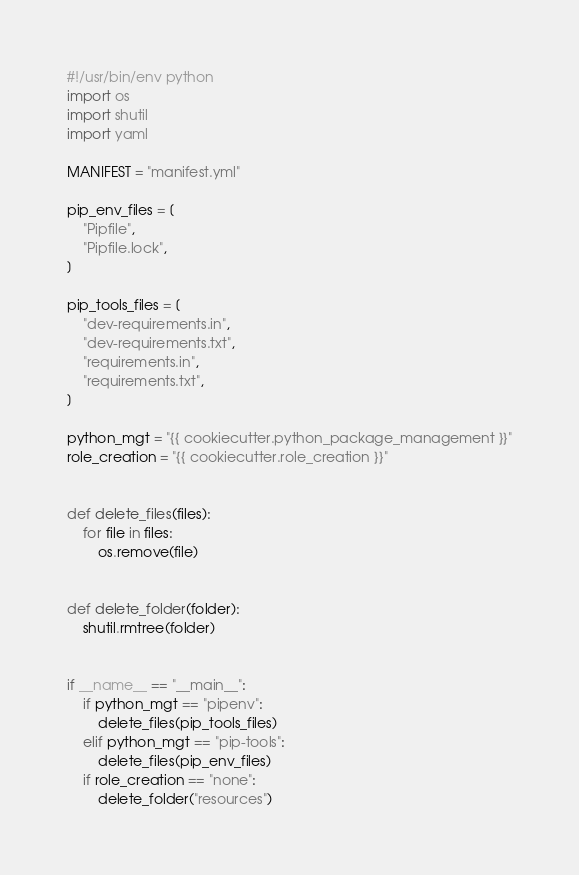<code> <loc_0><loc_0><loc_500><loc_500><_Python_>#!/usr/bin/env python
import os
import shutil
import yaml

MANIFEST = "manifest.yml"

pip_env_files = [
    "Pipfile",
    "Pipfile.lock",
]

pip_tools_files = [
    "dev-requirements.in",
    "dev-requirements.txt",
    "requirements.in",
    "requirements.txt",
]

python_mgt = "{{ cookiecutter.python_package_management }}"
role_creation = "{{ cookiecutter.role_creation }}"


def delete_files(files):
    for file in files:
        os.remove(file)


def delete_folder(folder):
    shutil.rmtree(folder)


if __name__ == "__main__":
    if python_mgt == "pipenv":
        delete_files(pip_tools_files)
    elif python_mgt == "pip-tools":
        delete_files(pip_env_files)
    if role_creation == "none":
        delete_folder("resources")
</code> 